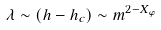Convert formula to latex. <formula><loc_0><loc_0><loc_500><loc_500>\lambda \sim ( h - h _ { c } ) \sim m ^ { 2 - X _ { \varphi } }</formula> 